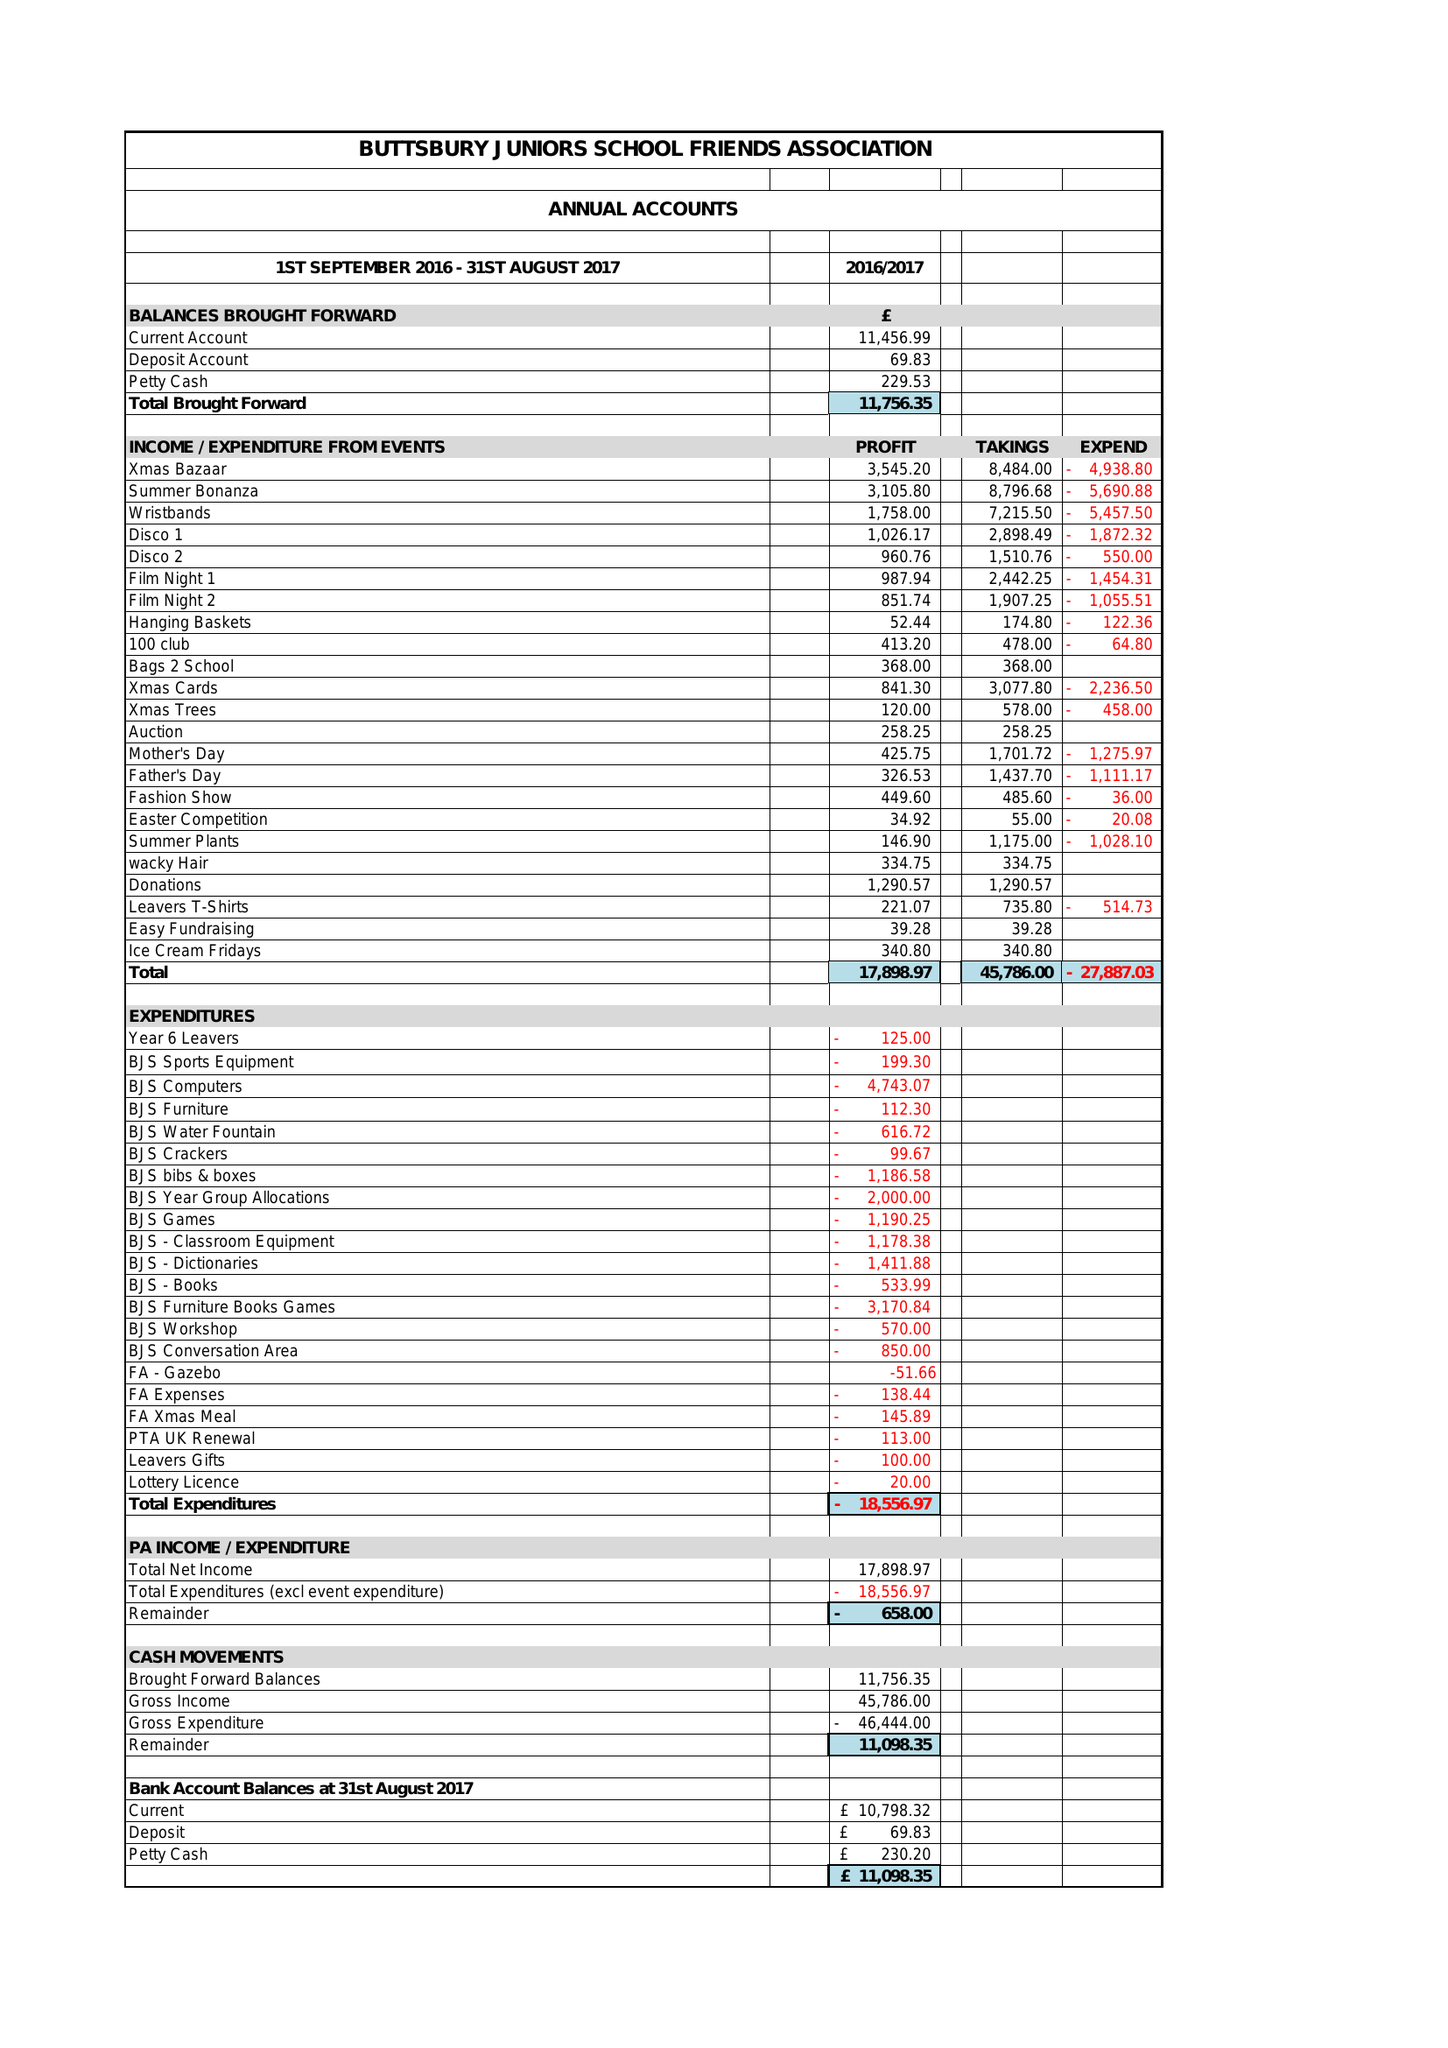What is the value for the address__post_town?
Answer the question using a single word or phrase. BILLERICAY 